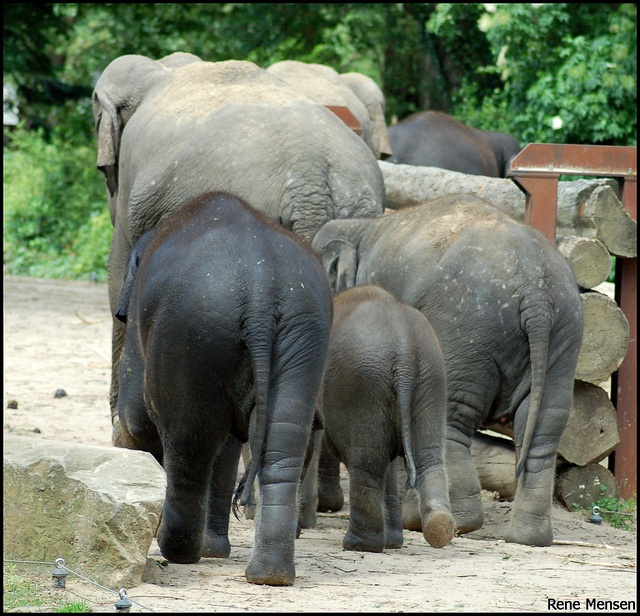Describe the objects in this image and their specific colors. I can see elephant in black, gray, and purple tones, elephant in black, gray, and darkgray tones, elephant in black, darkgray, beige, gray, and lightgray tones, elephant in black and gray tones, and elephant in black and gray tones in this image. 